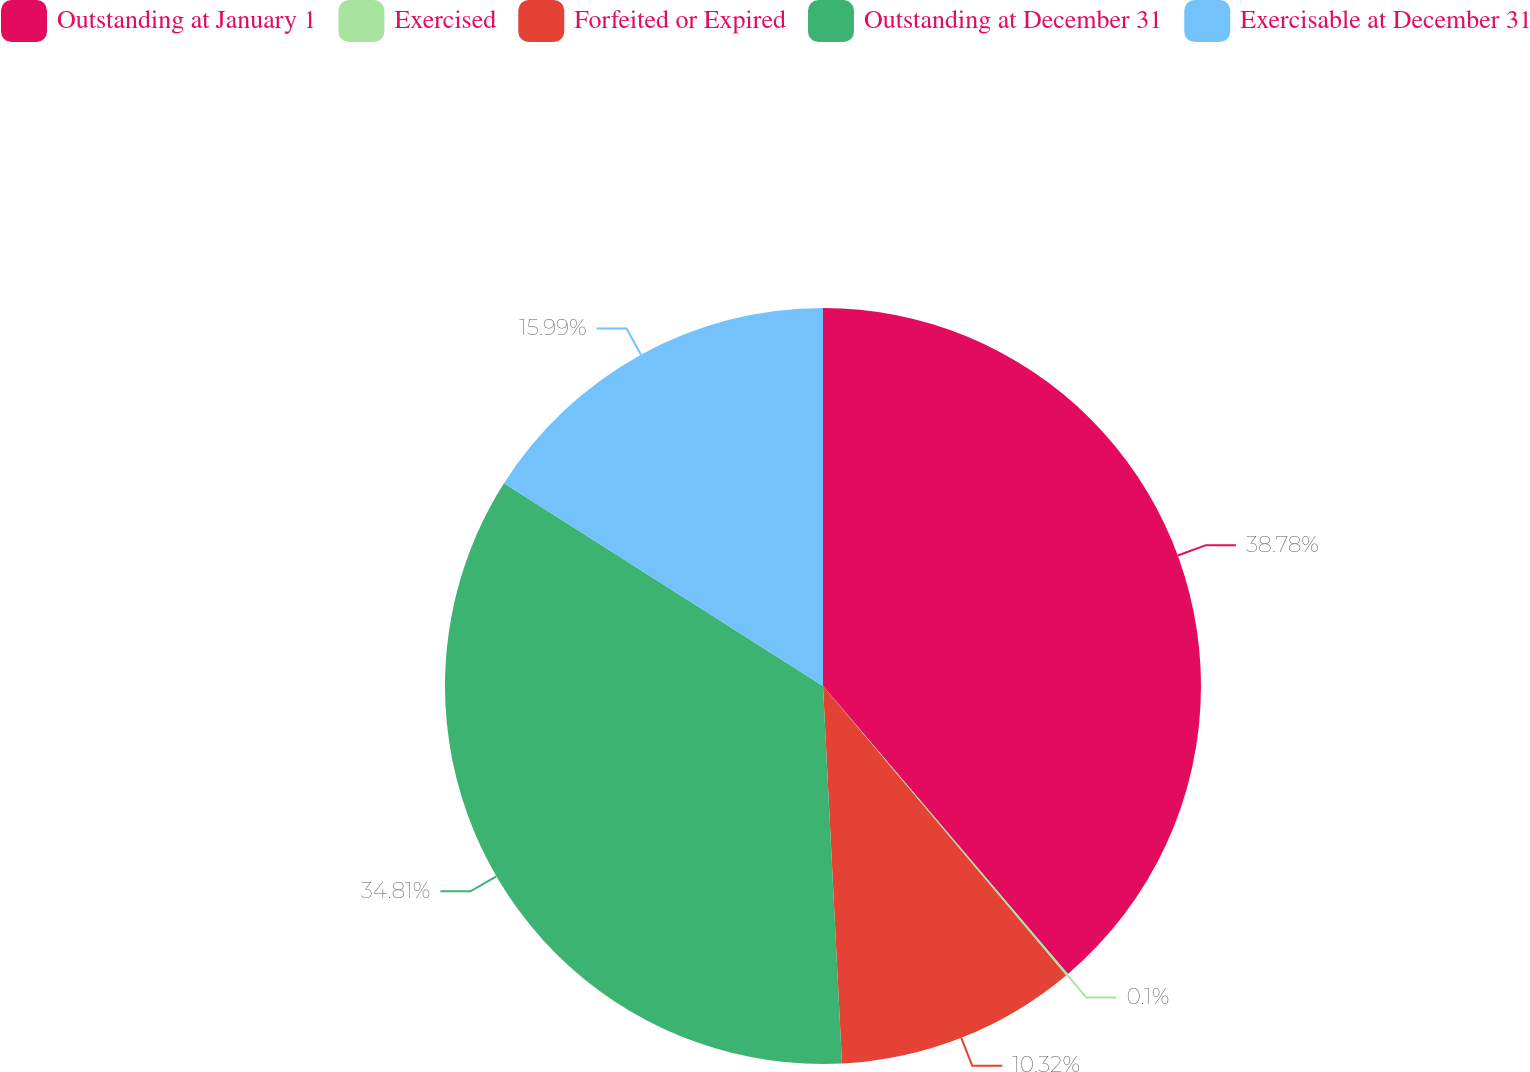Convert chart. <chart><loc_0><loc_0><loc_500><loc_500><pie_chart><fcel>Outstanding at January 1<fcel>Exercised<fcel>Forfeited or Expired<fcel>Outstanding at December 31<fcel>Exercisable at December 31<nl><fcel>38.78%<fcel>0.1%<fcel>10.32%<fcel>34.81%<fcel>15.99%<nl></chart> 